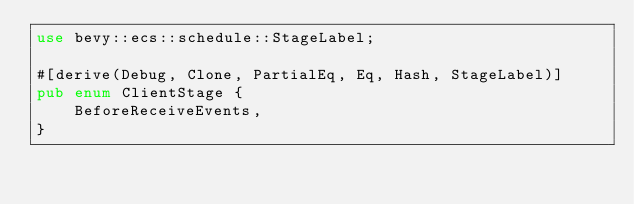<code> <loc_0><loc_0><loc_500><loc_500><_Rust_>use bevy::ecs::schedule::StageLabel;

#[derive(Debug, Clone, PartialEq, Eq, Hash, StageLabel)]
pub enum ClientStage {
    BeforeReceiveEvents,
}
</code> 